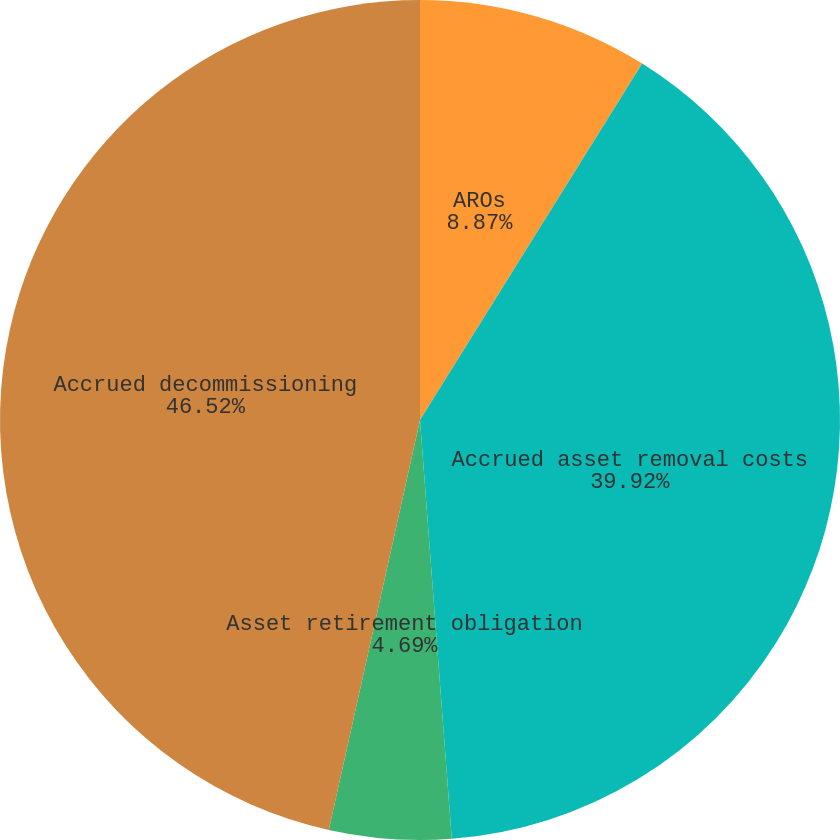Convert chart. <chart><loc_0><loc_0><loc_500><loc_500><pie_chart><fcel>AROs<fcel>Accrued asset removal costs<fcel>Asset retirement obligation<fcel>Accrued decommissioning<nl><fcel>8.87%<fcel>39.92%<fcel>4.69%<fcel>46.51%<nl></chart> 